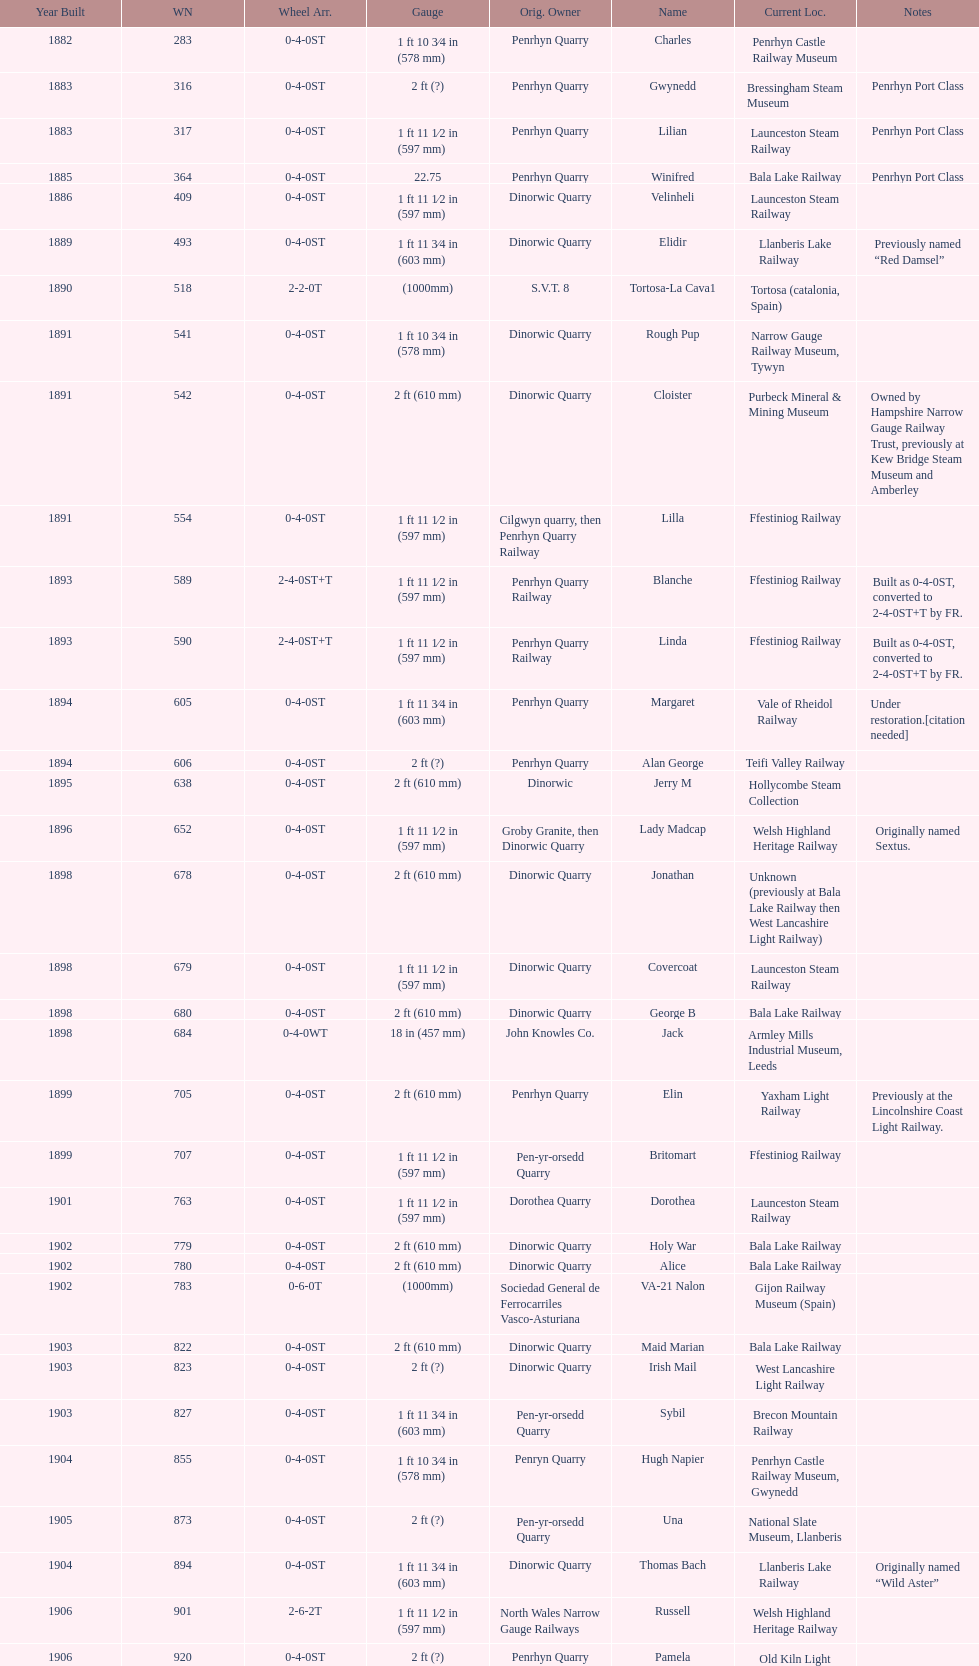Aside from 316, what was the other works number used in 1883? 317. 